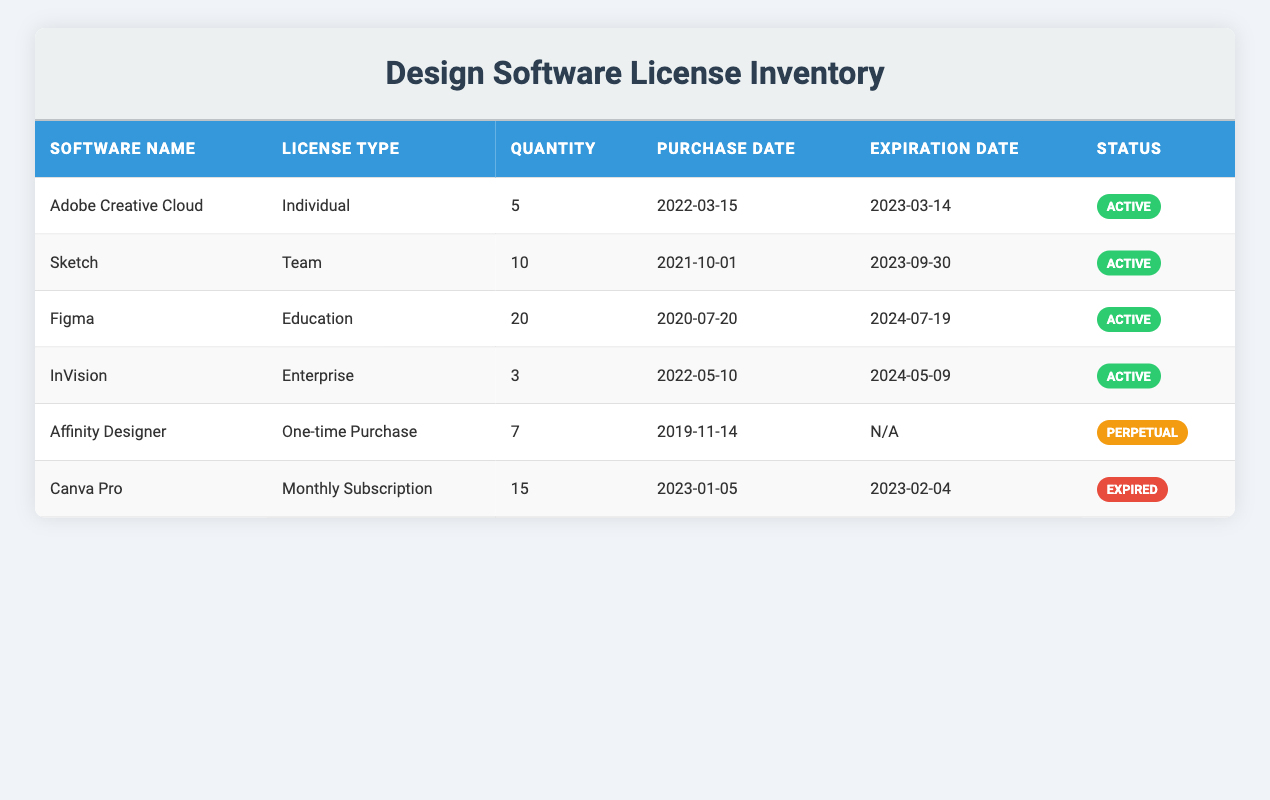What is the quantity of Adobe Creative Cloud licenses? The quantity of Adobe Creative Cloud licenses is listed directly in the table under the "Quantity" column for that specific software. It shows a value of 5.
Answer: 5 Which software has the highest quantity of licenses? By reviewing the "Quantity" column for all software, Figma has the highest quantity with 20 licenses.
Answer: Figma Are there any licenses that have expired? Looking in the "Status" column, Canva Pro is marked as "Expired," indicating that its license is no longer valid.
Answer: Yes What is the total quantity of active licenses? To find the total quantity of active licenses, we sum up the quantities from rows where the status is "Active," which are 5 (Adobe), 10 (Sketch), 20 (Figma), 3 (InVision) = 38.
Answer: 38 Is the license for Affinity Designer perpetual? The status for Affinity Designer is indicated as "Perpetual" in the table, confirming that it is a one-time purchase and does not expire.
Answer: Yes What is the difference in quantity between the software with the highest and lowest licenses? Figma has the highest quantity at 20 licenses, and InVision has the lowest at 3 licenses. The difference is 20 - 3 = 17.
Answer: 17 How many licenses need renewal in 2023? We check the expiration dates; Adobe Creative Cloud and Canva Pro both have expiration dates in 2023. Since Canva Pro is expired and Adobe needs renewal by 2023-03-14, we count only Adobe for renewal.
Answer: 1 Which software's license is the next to expire after October 2023? The only software with expiration later than October 2023 is Figma, with an expiration date of 2024-07-19. Therefore, it is the next license to expire after October 2023.
Answer: Figma What percentage of the total licenses are managed under individual license types? There are a total of 5 (Adobe) + 10 (Sketch) + 20 (Figma) + 3 (InVision) + 7 (Affinity) + 15 (Canva) = 60 licenses in total. Only Adobe has an individual license type with 5 licenses. The percentage is (5/60)*100 = 8.33%.
Answer: 8.33% 